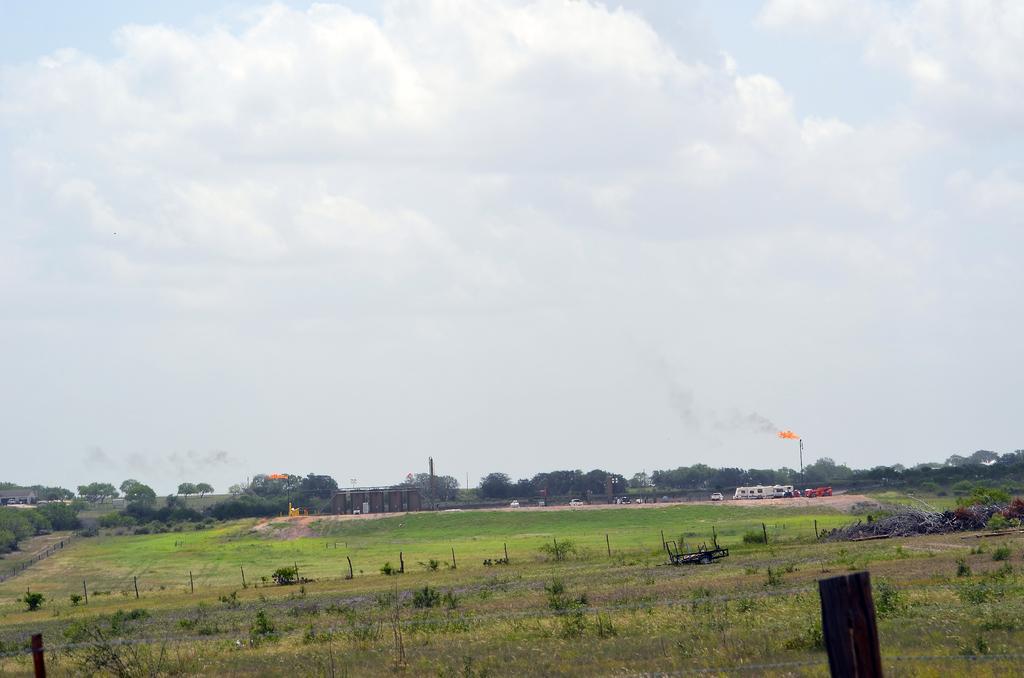Please provide a concise description of this image. In this picture I can see at the bottom there are plants, on the right side it looks like the fire, in the background there are trees. At the top there is the sky. 